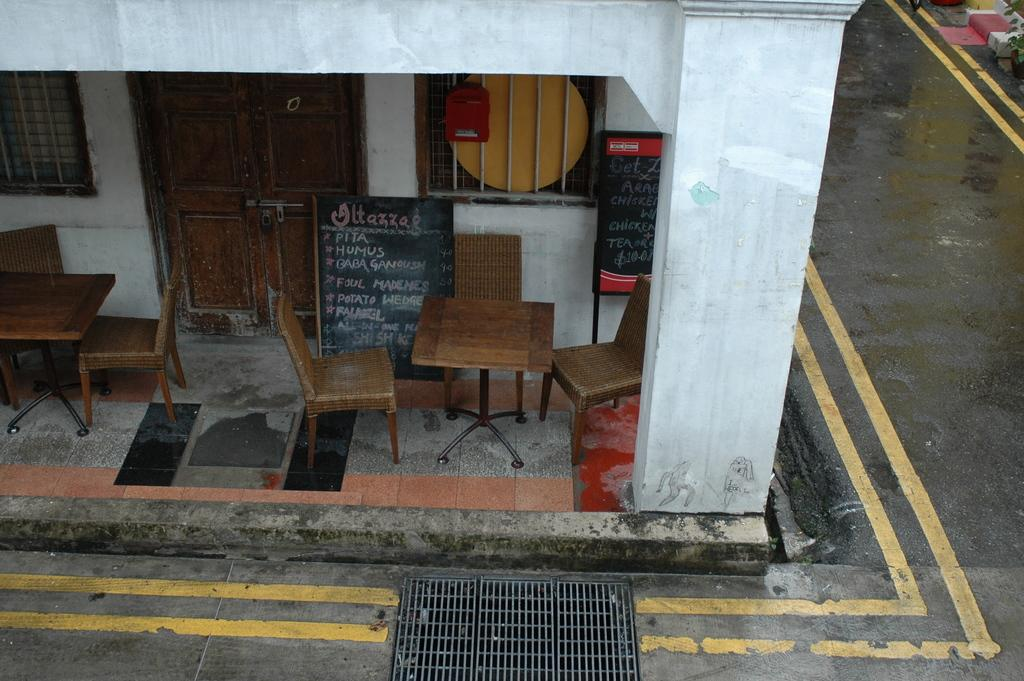What type of furniture is visible in the image? There are wooden chairs and tables in the image. Where are the chairs and tables located? The chairs and tables are in front of a house. What can be seen on the right side of the image? There is a road on the right side of the image. How many apples are on the wooden chairs in the image? There are no apples present in the image; only wooden chairs and tables are visible. 